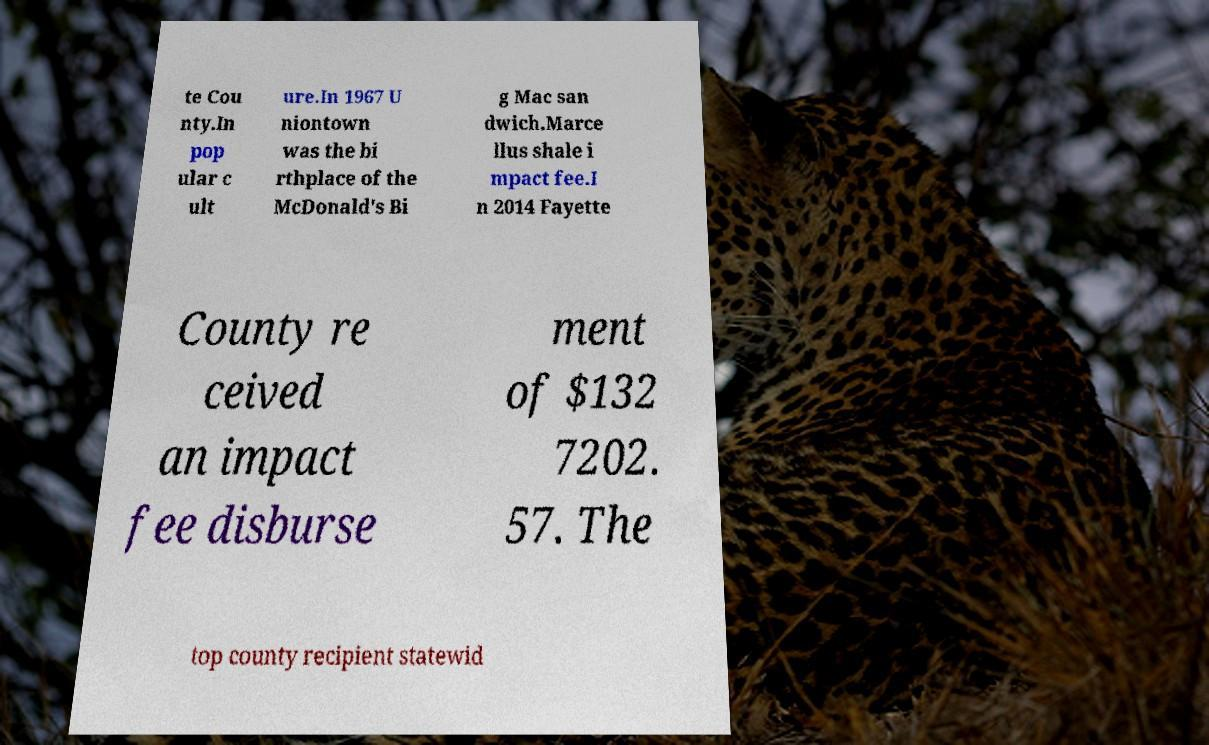Please identify and transcribe the text found in this image. te Cou nty.In pop ular c ult ure.In 1967 U niontown was the bi rthplace of the McDonald's Bi g Mac san dwich.Marce llus shale i mpact fee.I n 2014 Fayette County re ceived an impact fee disburse ment of $132 7202. 57. The top county recipient statewid 